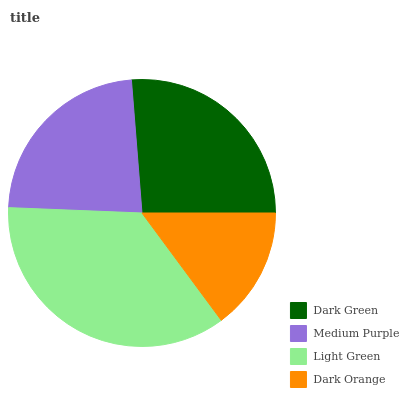Is Dark Orange the minimum?
Answer yes or no. Yes. Is Light Green the maximum?
Answer yes or no. Yes. Is Medium Purple the minimum?
Answer yes or no. No. Is Medium Purple the maximum?
Answer yes or no. No. Is Dark Green greater than Medium Purple?
Answer yes or no. Yes. Is Medium Purple less than Dark Green?
Answer yes or no. Yes. Is Medium Purple greater than Dark Green?
Answer yes or no. No. Is Dark Green less than Medium Purple?
Answer yes or no. No. Is Dark Green the high median?
Answer yes or no. Yes. Is Medium Purple the low median?
Answer yes or no. Yes. Is Medium Purple the high median?
Answer yes or no. No. Is Light Green the low median?
Answer yes or no. No. 